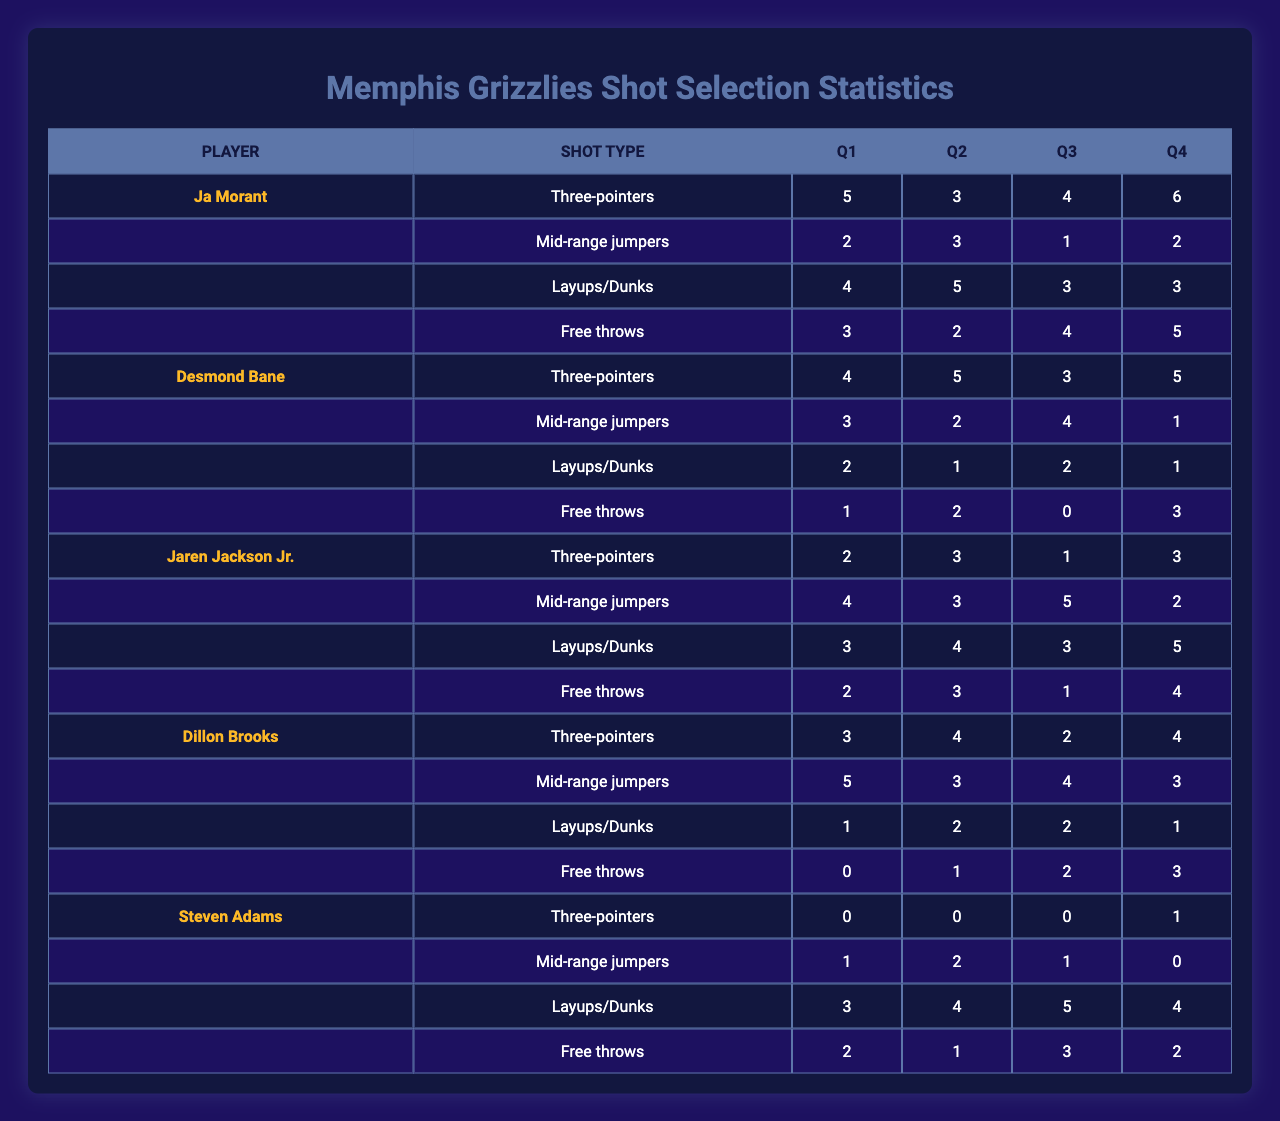What is the total number of layups/dunks made by Ja Morant in Q4? In the table, Ja Morant has made 3 layups/dunks in Q4 as seen in the data under Q4 and for the shot type Layups/Dunks.
Answer: 3 Which player had the highest number of three-pointers in Q2? By checking the three-pointer column for Q2, Desmond Bane made 5 three-pointers, which is the highest among all players.
Answer: Desmond Bane How many total free throws did Steven Adams attempt over all quarters? To find this, we sum the free throw attempts: 2 (Q1) + 1 (Q2) + 3 (Q3) + 2 (Q4) = 8.
Answer: 8 What was Jaren Jackson Jr.'s average shots attempted per quarter for mid-range jumpers? Jaren Jackson Jr. attempted mid-range shots: 4 (Q1), 3 (Q2), 5 (Q3), and 2 (Q4). Summing these (4 + 3 + 5 + 2 = 14) and dividing by 4 gives an average of 3.5.
Answer: 3.5 Is it true that Dillon Brooks made more free throws in Q3 than in Q1? In Q3, Dillon Brooks made 2 free throws and in Q1, he made 0. Since 2 is greater than 0, the statement is true.
Answer: True Who had the highest total points from three-pointers across all quarters? We calculate the total three-pointers made across all quarters: Ja Morant (5+3+4+6 = 18), Desmond Bane (4+5+3+5 = 17), Jaren Jackson Jr. (2+3+1+3 = 9), Dillon Brooks (3+4+2+4 = 13), and Steven Adams (0+0+0+1 = 1). Ja Morant has the highest with 18 total points from three-pointers.
Answer: Ja Morant Which player had the lowest number of attempts for layups/dunks in Q3? Looking at the table, the attempts for layups/dunks in Q3 are: Ja Morant (3), Desmond Bane (2), Jaren Jackson Jr. (3), Dillon Brooks (2), and Steven Adams (5). Desmond Bane and Dillon Brooks both made only 2 attempts, making them the lowest for this quarter.
Answer: Desmond Bane and Dillon Brooks What is the difference in the number of mid-range jumpers attempted by Ja Morant in Q1 and Q4? In Q1, Ja Morant attempted 2 mid-range jumpers, and in Q4, he attempted 2. The difference is 2 - 2 = 0.
Answer: 0 